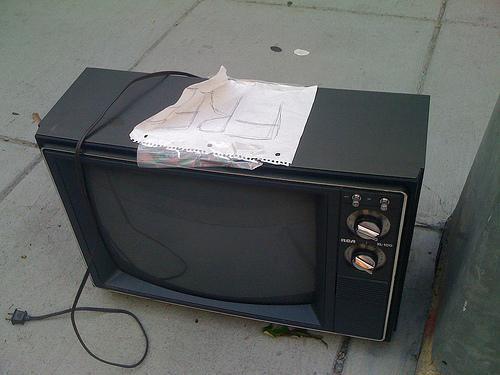How many TVs are there?
Give a very brief answer. 1. 